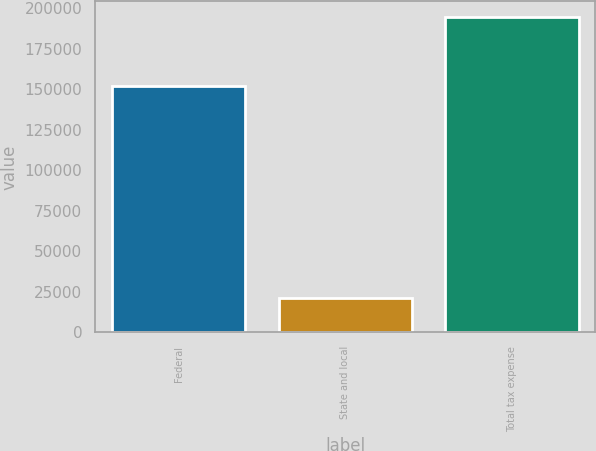Convert chart. <chart><loc_0><loc_0><loc_500><loc_500><bar_chart><fcel>Federal<fcel>State and local<fcel>Total tax expense<nl><fcel>152140<fcel>21095<fcel>194287<nl></chart> 